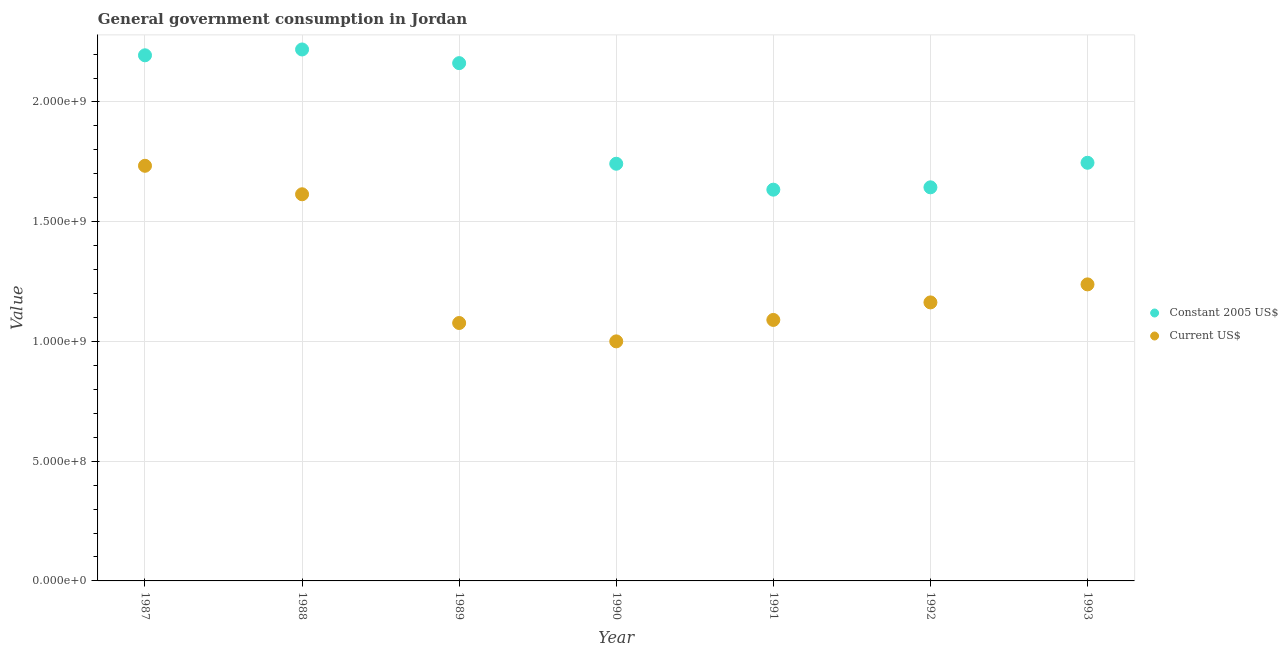What is the value consumed in constant 2005 us$ in 1990?
Provide a succinct answer. 1.74e+09. Across all years, what is the maximum value consumed in current us$?
Offer a very short reply. 1.73e+09. Across all years, what is the minimum value consumed in constant 2005 us$?
Your answer should be very brief. 1.63e+09. What is the total value consumed in current us$ in the graph?
Give a very brief answer. 8.92e+09. What is the difference between the value consumed in constant 2005 us$ in 1989 and that in 1992?
Provide a succinct answer. 5.19e+08. What is the difference between the value consumed in constant 2005 us$ in 1989 and the value consumed in current us$ in 1991?
Make the answer very short. 1.07e+09. What is the average value consumed in constant 2005 us$ per year?
Provide a short and direct response. 1.91e+09. In the year 1993, what is the difference between the value consumed in current us$ and value consumed in constant 2005 us$?
Offer a very short reply. -5.08e+08. What is the ratio of the value consumed in constant 2005 us$ in 1990 to that in 1991?
Make the answer very short. 1.07. Is the value consumed in constant 2005 us$ in 1991 less than that in 1993?
Provide a succinct answer. Yes. Is the difference between the value consumed in current us$ in 1991 and 1993 greater than the difference between the value consumed in constant 2005 us$ in 1991 and 1993?
Your answer should be very brief. No. What is the difference between the highest and the second highest value consumed in constant 2005 us$?
Keep it short and to the point. 2.43e+07. What is the difference between the highest and the lowest value consumed in constant 2005 us$?
Make the answer very short. 5.85e+08. Is the sum of the value consumed in current us$ in 1987 and 1991 greater than the maximum value consumed in constant 2005 us$ across all years?
Provide a succinct answer. Yes. Is the value consumed in constant 2005 us$ strictly greater than the value consumed in current us$ over the years?
Your answer should be very brief. Yes. Is the value consumed in current us$ strictly less than the value consumed in constant 2005 us$ over the years?
Offer a very short reply. Yes. How many dotlines are there?
Provide a succinct answer. 2. Does the graph contain grids?
Offer a very short reply. Yes. How are the legend labels stacked?
Your response must be concise. Vertical. What is the title of the graph?
Make the answer very short. General government consumption in Jordan. Does "Food" appear as one of the legend labels in the graph?
Provide a succinct answer. No. What is the label or title of the Y-axis?
Your answer should be compact. Value. What is the Value in Constant 2005 US$ in 1987?
Your answer should be compact. 2.19e+09. What is the Value in Current US$ in 1987?
Give a very brief answer. 1.73e+09. What is the Value of Constant 2005 US$ in 1988?
Provide a short and direct response. 2.22e+09. What is the Value of Current US$ in 1988?
Give a very brief answer. 1.61e+09. What is the Value of Constant 2005 US$ in 1989?
Provide a short and direct response. 2.16e+09. What is the Value of Current US$ in 1989?
Make the answer very short. 1.08e+09. What is the Value in Constant 2005 US$ in 1990?
Give a very brief answer. 1.74e+09. What is the Value of Current US$ in 1990?
Make the answer very short. 1.00e+09. What is the Value in Constant 2005 US$ in 1991?
Your answer should be compact. 1.63e+09. What is the Value in Current US$ in 1991?
Your answer should be compact. 1.09e+09. What is the Value of Constant 2005 US$ in 1992?
Ensure brevity in your answer.  1.64e+09. What is the Value of Current US$ in 1992?
Make the answer very short. 1.16e+09. What is the Value in Constant 2005 US$ in 1993?
Ensure brevity in your answer.  1.75e+09. What is the Value of Current US$ in 1993?
Offer a very short reply. 1.24e+09. Across all years, what is the maximum Value of Constant 2005 US$?
Ensure brevity in your answer.  2.22e+09. Across all years, what is the maximum Value of Current US$?
Your answer should be compact. 1.73e+09. Across all years, what is the minimum Value in Constant 2005 US$?
Provide a succinct answer. 1.63e+09. Across all years, what is the minimum Value of Current US$?
Provide a short and direct response. 1.00e+09. What is the total Value of Constant 2005 US$ in the graph?
Offer a terse response. 1.33e+1. What is the total Value of Current US$ in the graph?
Keep it short and to the point. 8.92e+09. What is the difference between the Value in Constant 2005 US$ in 1987 and that in 1988?
Ensure brevity in your answer.  -2.43e+07. What is the difference between the Value in Current US$ in 1987 and that in 1988?
Provide a short and direct response. 1.19e+08. What is the difference between the Value of Constant 2005 US$ in 1987 and that in 1989?
Keep it short and to the point. 3.27e+07. What is the difference between the Value in Current US$ in 1987 and that in 1989?
Make the answer very short. 6.56e+08. What is the difference between the Value in Constant 2005 US$ in 1987 and that in 1990?
Provide a succinct answer. 4.53e+08. What is the difference between the Value in Current US$ in 1987 and that in 1990?
Your response must be concise. 7.33e+08. What is the difference between the Value of Constant 2005 US$ in 1987 and that in 1991?
Ensure brevity in your answer.  5.61e+08. What is the difference between the Value of Current US$ in 1987 and that in 1991?
Ensure brevity in your answer.  6.44e+08. What is the difference between the Value in Constant 2005 US$ in 1987 and that in 1992?
Your response must be concise. 5.51e+08. What is the difference between the Value in Current US$ in 1987 and that in 1992?
Your answer should be very brief. 5.70e+08. What is the difference between the Value of Constant 2005 US$ in 1987 and that in 1993?
Make the answer very short. 4.49e+08. What is the difference between the Value of Current US$ in 1987 and that in 1993?
Offer a terse response. 4.95e+08. What is the difference between the Value of Constant 2005 US$ in 1988 and that in 1989?
Your answer should be compact. 5.71e+07. What is the difference between the Value of Current US$ in 1988 and that in 1989?
Offer a terse response. 5.38e+08. What is the difference between the Value of Constant 2005 US$ in 1988 and that in 1990?
Provide a succinct answer. 4.77e+08. What is the difference between the Value in Current US$ in 1988 and that in 1990?
Your response must be concise. 6.14e+08. What is the difference between the Value in Constant 2005 US$ in 1988 and that in 1991?
Keep it short and to the point. 5.85e+08. What is the difference between the Value in Current US$ in 1988 and that in 1991?
Keep it short and to the point. 5.25e+08. What is the difference between the Value of Constant 2005 US$ in 1988 and that in 1992?
Offer a terse response. 5.76e+08. What is the difference between the Value in Current US$ in 1988 and that in 1992?
Make the answer very short. 4.52e+08. What is the difference between the Value in Constant 2005 US$ in 1988 and that in 1993?
Provide a succinct answer. 4.73e+08. What is the difference between the Value in Current US$ in 1988 and that in 1993?
Your response must be concise. 3.76e+08. What is the difference between the Value in Constant 2005 US$ in 1989 and that in 1990?
Ensure brevity in your answer.  4.20e+08. What is the difference between the Value in Current US$ in 1989 and that in 1990?
Offer a very short reply. 7.67e+07. What is the difference between the Value of Constant 2005 US$ in 1989 and that in 1991?
Keep it short and to the point. 5.28e+08. What is the difference between the Value of Current US$ in 1989 and that in 1991?
Offer a very short reply. -1.28e+07. What is the difference between the Value in Constant 2005 US$ in 1989 and that in 1992?
Your answer should be compact. 5.19e+08. What is the difference between the Value of Current US$ in 1989 and that in 1992?
Offer a terse response. -8.60e+07. What is the difference between the Value in Constant 2005 US$ in 1989 and that in 1993?
Give a very brief answer. 4.16e+08. What is the difference between the Value in Current US$ in 1989 and that in 1993?
Make the answer very short. -1.61e+08. What is the difference between the Value of Constant 2005 US$ in 1990 and that in 1991?
Offer a very short reply. 1.08e+08. What is the difference between the Value of Current US$ in 1990 and that in 1991?
Your response must be concise. -8.95e+07. What is the difference between the Value of Constant 2005 US$ in 1990 and that in 1992?
Give a very brief answer. 9.85e+07. What is the difference between the Value in Current US$ in 1990 and that in 1992?
Your answer should be very brief. -1.63e+08. What is the difference between the Value in Constant 2005 US$ in 1990 and that in 1993?
Keep it short and to the point. -4.03e+06. What is the difference between the Value in Current US$ in 1990 and that in 1993?
Give a very brief answer. -2.38e+08. What is the difference between the Value in Constant 2005 US$ in 1991 and that in 1992?
Provide a short and direct response. -9.79e+06. What is the difference between the Value in Current US$ in 1991 and that in 1992?
Offer a very short reply. -7.32e+07. What is the difference between the Value in Constant 2005 US$ in 1991 and that in 1993?
Give a very brief answer. -1.12e+08. What is the difference between the Value of Current US$ in 1991 and that in 1993?
Your answer should be very brief. -1.48e+08. What is the difference between the Value in Constant 2005 US$ in 1992 and that in 1993?
Provide a short and direct response. -1.02e+08. What is the difference between the Value of Current US$ in 1992 and that in 1993?
Your response must be concise. -7.53e+07. What is the difference between the Value of Constant 2005 US$ in 1987 and the Value of Current US$ in 1988?
Make the answer very short. 5.80e+08. What is the difference between the Value of Constant 2005 US$ in 1987 and the Value of Current US$ in 1989?
Offer a terse response. 1.12e+09. What is the difference between the Value of Constant 2005 US$ in 1987 and the Value of Current US$ in 1990?
Your answer should be compact. 1.19e+09. What is the difference between the Value of Constant 2005 US$ in 1987 and the Value of Current US$ in 1991?
Provide a succinct answer. 1.11e+09. What is the difference between the Value of Constant 2005 US$ in 1987 and the Value of Current US$ in 1992?
Keep it short and to the point. 1.03e+09. What is the difference between the Value in Constant 2005 US$ in 1987 and the Value in Current US$ in 1993?
Offer a terse response. 9.57e+08. What is the difference between the Value in Constant 2005 US$ in 1988 and the Value in Current US$ in 1989?
Give a very brief answer. 1.14e+09. What is the difference between the Value in Constant 2005 US$ in 1988 and the Value in Current US$ in 1990?
Your answer should be very brief. 1.22e+09. What is the difference between the Value in Constant 2005 US$ in 1988 and the Value in Current US$ in 1991?
Your answer should be very brief. 1.13e+09. What is the difference between the Value in Constant 2005 US$ in 1988 and the Value in Current US$ in 1992?
Offer a terse response. 1.06e+09. What is the difference between the Value of Constant 2005 US$ in 1988 and the Value of Current US$ in 1993?
Your answer should be compact. 9.81e+08. What is the difference between the Value of Constant 2005 US$ in 1989 and the Value of Current US$ in 1990?
Make the answer very short. 1.16e+09. What is the difference between the Value of Constant 2005 US$ in 1989 and the Value of Current US$ in 1991?
Keep it short and to the point. 1.07e+09. What is the difference between the Value in Constant 2005 US$ in 1989 and the Value in Current US$ in 1992?
Your response must be concise. 9.99e+08. What is the difference between the Value of Constant 2005 US$ in 1989 and the Value of Current US$ in 1993?
Ensure brevity in your answer.  9.24e+08. What is the difference between the Value of Constant 2005 US$ in 1990 and the Value of Current US$ in 1991?
Ensure brevity in your answer.  6.52e+08. What is the difference between the Value of Constant 2005 US$ in 1990 and the Value of Current US$ in 1992?
Offer a very short reply. 5.79e+08. What is the difference between the Value of Constant 2005 US$ in 1990 and the Value of Current US$ in 1993?
Offer a terse response. 5.04e+08. What is the difference between the Value in Constant 2005 US$ in 1991 and the Value in Current US$ in 1992?
Your response must be concise. 4.71e+08. What is the difference between the Value in Constant 2005 US$ in 1991 and the Value in Current US$ in 1993?
Ensure brevity in your answer.  3.96e+08. What is the difference between the Value in Constant 2005 US$ in 1992 and the Value in Current US$ in 1993?
Make the answer very short. 4.05e+08. What is the average Value in Constant 2005 US$ per year?
Your answer should be very brief. 1.91e+09. What is the average Value in Current US$ per year?
Ensure brevity in your answer.  1.27e+09. In the year 1987, what is the difference between the Value of Constant 2005 US$ and Value of Current US$?
Your answer should be very brief. 4.61e+08. In the year 1988, what is the difference between the Value of Constant 2005 US$ and Value of Current US$?
Make the answer very short. 6.05e+08. In the year 1989, what is the difference between the Value of Constant 2005 US$ and Value of Current US$?
Keep it short and to the point. 1.09e+09. In the year 1990, what is the difference between the Value in Constant 2005 US$ and Value in Current US$?
Offer a terse response. 7.42e+08. In the year 1991, what is the difference between the Value in Constant 2005 US$ and Value in Current US$?
Your answer should be compact. 5.44e+08. In the year 1992, what is the difference between the Value of Constant 2005 US$ and Value of Current US$?
Keep it short and to the point. 4.81e+08. In the year 1993, what is the difference between the Value in Constant 2005 US$ and Value in Current US$?
Make the answer very short. 5.08e+08. What is the ratio of the Value of Constant 2005 US$ in 1987 to that in 1988?
Keep it short and to the point. 0.99. What is the ratio of the Value of Current US$ in 1987 to that in 1988?
Offer a terse response. 1.07. What is the ratio of the Value of Constant 2005 US$ in 1987 to that in 1989?
Offer a very short reply. 1.02. What is the ratio of the Value of Current US$ in 1987 to that in 1989?
Your response must be concise. 1.61. What is the ratio of the Value of Constant 2005 US$ in 1987 to that in 1990?
Your response must be concise. 1.26. What is the ratio of the Value in Current US$ in 1987 to that in 1990?
Provide a short and direct response. 1.73. What is the ratio of the Value of Constant 2005 US$ in 1987 to that in 1991?
Provide a short and direct response. 1.34. What is the ratio of the Value of Current US$ in 1987 to that in 1991?
Keep it short and to the point. 1.59. What is the ratio of the Value of Constant 2005 US$ in 1987 to that in 1992?
Your answer should be compact. 1.34. What is the ratio of the Value in Current US$ in 1987 to that in 1992?
Give a very brief answer. 1.49. What is the ratio of the Value of Constant 2005 US$ in 1987 to that in 1993?
Provide a short and direct response. 1.26. What is the ratio of the Value in Current US$ in 1987 to that in 1993?
Provide a short and direct response. 1.4. What is the ratio of the Value of Constant 2005 US$ in 1988 to that in 1989?
Keep it short and to the point. 1.03. What is the ratio of the Value of Current US$ in 1988 to that in 1989?
Your answer should be compact. 1.5. What is the ratio of the Value of Constant 2005 US$ in 1988 to that in 1990?
Ensure brevity in your answer.  1.27. What is the ratio of the Value of Current US$ in 1988 to that in 1990?
Your answer should be compact. 1.61. What is the ratio of the Value in Constant 2005 US$ in 1988 to that in 1991?
Keep it short and to the point. 1.36. What is the ratio of the Value of Current US$ in 1988 to that in 1991?
Ensure brevity in your answer.  1.48. What is the ratio of the Value of Constant 2005 US$ in 1988 to that in 1992?
Make the answer very short. 1.35. What is the ratio of the Value of Current US$ in 1988 to that in 1992?
Your answer should be compact. 1.39. What is the ratio of the Value in Constant 2005 US$ in 1988 to that in 1993?
Offer a very short reply. 1.27. What is the ratio of the Value of Current US$ in 1988 to that in 1993?
Make the answer very short. 1.3. What is the ratio of the Value in Constant 2005 US$ in 1989 to that in 1990?
Your answer should be compact. 1.24. What is the ratio of the Value of Current US$ in 1989 to that in 1990?
Make the answer very short. 1.08. What is the ratio of the Value of Constant 2005 US$ in 1989 to that in 1991?
Your answer should be compact. 1.32. What is the ratio of the Value of Constant 2005 US$ in 1989 to that in 1992?
Your answer should be compact. 1.32. What is the ratio of the Value in Current US$ in 1989 to that in 1992?
Provide a short and direct response. 0.93. What is the ratio of the Value in Constant 2005 US$ in 1989 to that in 1993?
Your answer should be very brief. 1.24. What is the ratio of the Value in Current US$ in 1989 to that in 1993?
Offer a terse response. 0.87. What is the ratio of the Value of Constant 2005 US$ in 1990 to that in 1991?
Provide a short and direct response. 1.07. What is the ratio of the Value in Current US$ in 1990 to that in 1991?
Make the answer very short. 0.92. What is the ratio of the Value in Constant 2005 US$ in 1990 to that in 1992?
Your answer should be compact. 1.06. What is the ratio of the Value in Current US$ in 1990 to that in 1992?
Your answer should be very brief. 0.86. What is the ratio of the Value of Current US$ in 1990 to that in 1993?
Give a very brief answer. 0.81. What is the ratio of the Value of Constant 2005 US$ in 1991 to that in 1992?
Make the answer very short. 0.99. What is the ratio of the Value in Current US$ in 1991 to that in 1992?
Your answer should be very brief. 0.94. What is the ratio of the Value of Constant 2005 US$ in 1991 to that in 1993?
Provide a short and direct response. 0.94. What is the ratio of the Value of Current US$ in 1991 to that in 1993?
Your answer should be very brief. 0.88. What is the ratio of the Value in Constant 2005 US$ in 1992 to that in 1993?
Your answer should be very brief. 0.94. What is the ratio of the Value in Current US$ in 1992 to that in 1993?
Your response must be concise. 0.94. What is the difference between the highest and the second highest Value in Constant 2005 US$?
Keep it short and to the point. 2.43e+07. What is the difference between the highest and the second highest Value of Current US$?
Give a very brief answer. 1.19e+08. What is the difference between the highest and the lowest Value of Constant 2005 US$?
Your answer should be very brief. 5.85e+08. What is the difference between the highest and the lowest Value of Current US$?
Your response must be concise. 7.33e+08. 